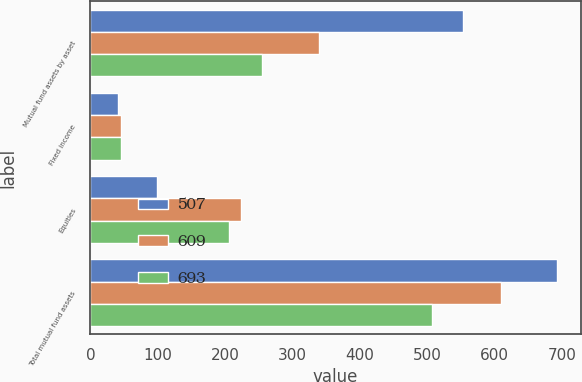<chart> <loc_0><loc_0><loc_500><loc_500><stacked_bar_chart><ecel><fcel>Mutual fund assets by asset<fcel>Fixed income<fcel>Equities<fcel>Total mutual fund assets<nl><fcel>507<fcel>553<fcel>41<fcel>99<fcel>693<nl><fcel>609<fcel>339<fcel>46<fcel>224<fcel>609<nl><fcel>693<fcel>255<fcel>46<fcel>206<fcel>507<nl></chart> 